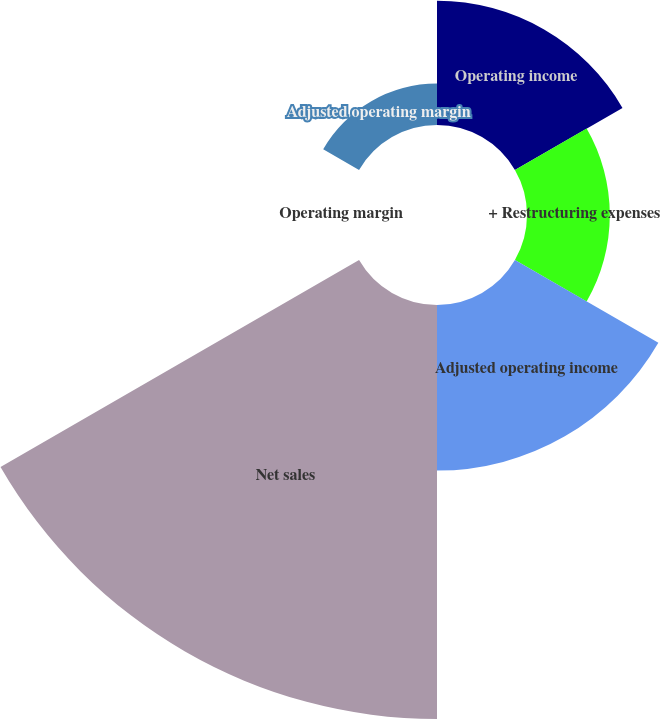Convert chart. <chart><loc_0><loc_0><loc_500><loc_500><pie_chart><fcel>Operating income<fcel>+ Restructuring expenses<fcel>Adjusted operating income<fcel>Net sales<fcel>Operating margin<fcel>Adjusted operating margin<nl><fcel>15.0%<fcel>10.0%<fcel>20.0%<fcel>50.0%<fcel>0.0%<fcel>5.0%<nl></chart> 